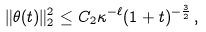Convert formula to latex. <formula><loc_0><loc_0><loc_500><loc_500>\| \theta ( t ) \| _ { 2 } ^ { 2 } \leq C _ { 2 } \kappa ^ { - \ell } ( 1 + t ) ^ { - \frac { 3 } { 2 } } \, ,</formula> 